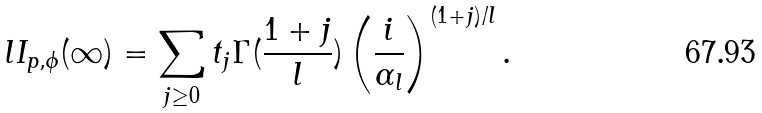Convert formula to latex. <formula><loc_0><loc_0><loc_500><loc_500>l I _ { p , \phi } ( \infty ) = \sum _ { j \geq 0 } t _ { j } \Gamma ( \frac { 1 + j } { l } ) \left ( \frac { i } { \alpha _ { l } } \right ) ^ { ( 1 + j ) / l } .</formula> 